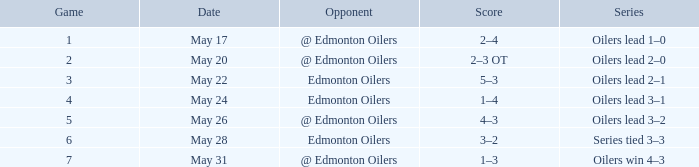When did the 2-3 overtime outcome occur? May 20. 